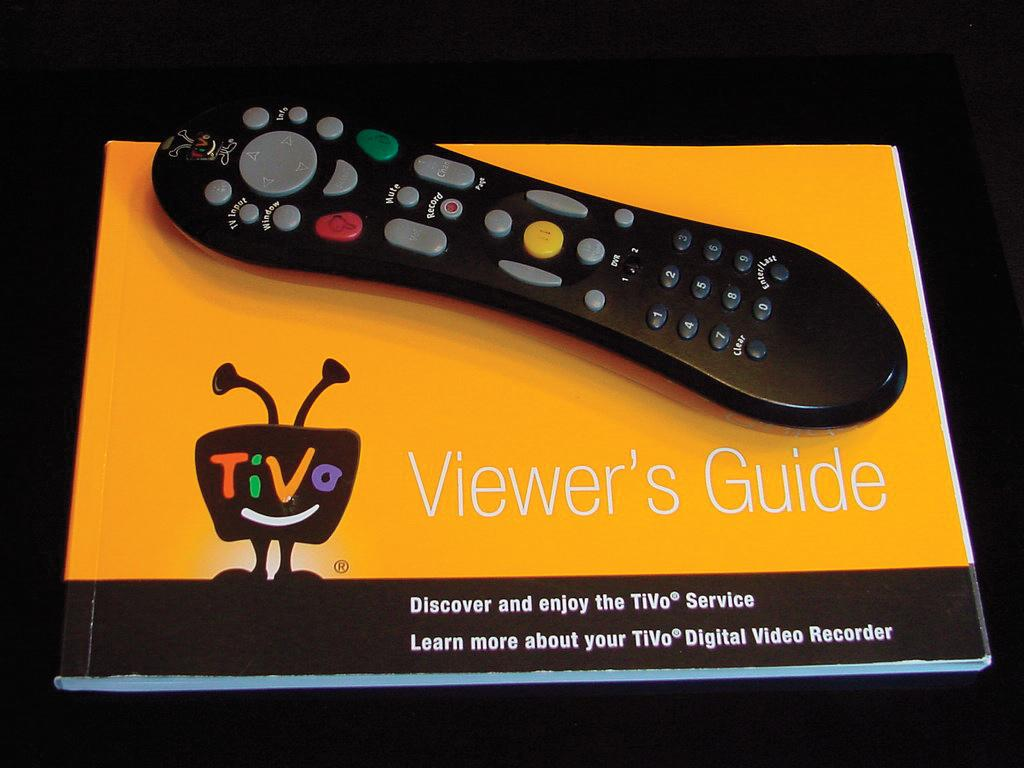<image>
Provide a brief description of the given image. A remote control lies on top of an orange viewer's guide for using TiVo. 